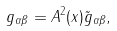<formula> <loc_0><loc_0><loc_500><loc_500>g _ { \alpha \beta } = A ^ { 2 } ( x ) \tilde { g } _ { \alpha \beta } ,</formula> 